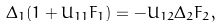<formula> <loc_0><loc_0><loc_500><loc_500>\Delta _ { 1 } ( 1 + U _ { 1 1 } F _ { 1 } ) = - U _ { 1 2 } \Delta _ { 2 } F _ { 2 } , \\</formula> 